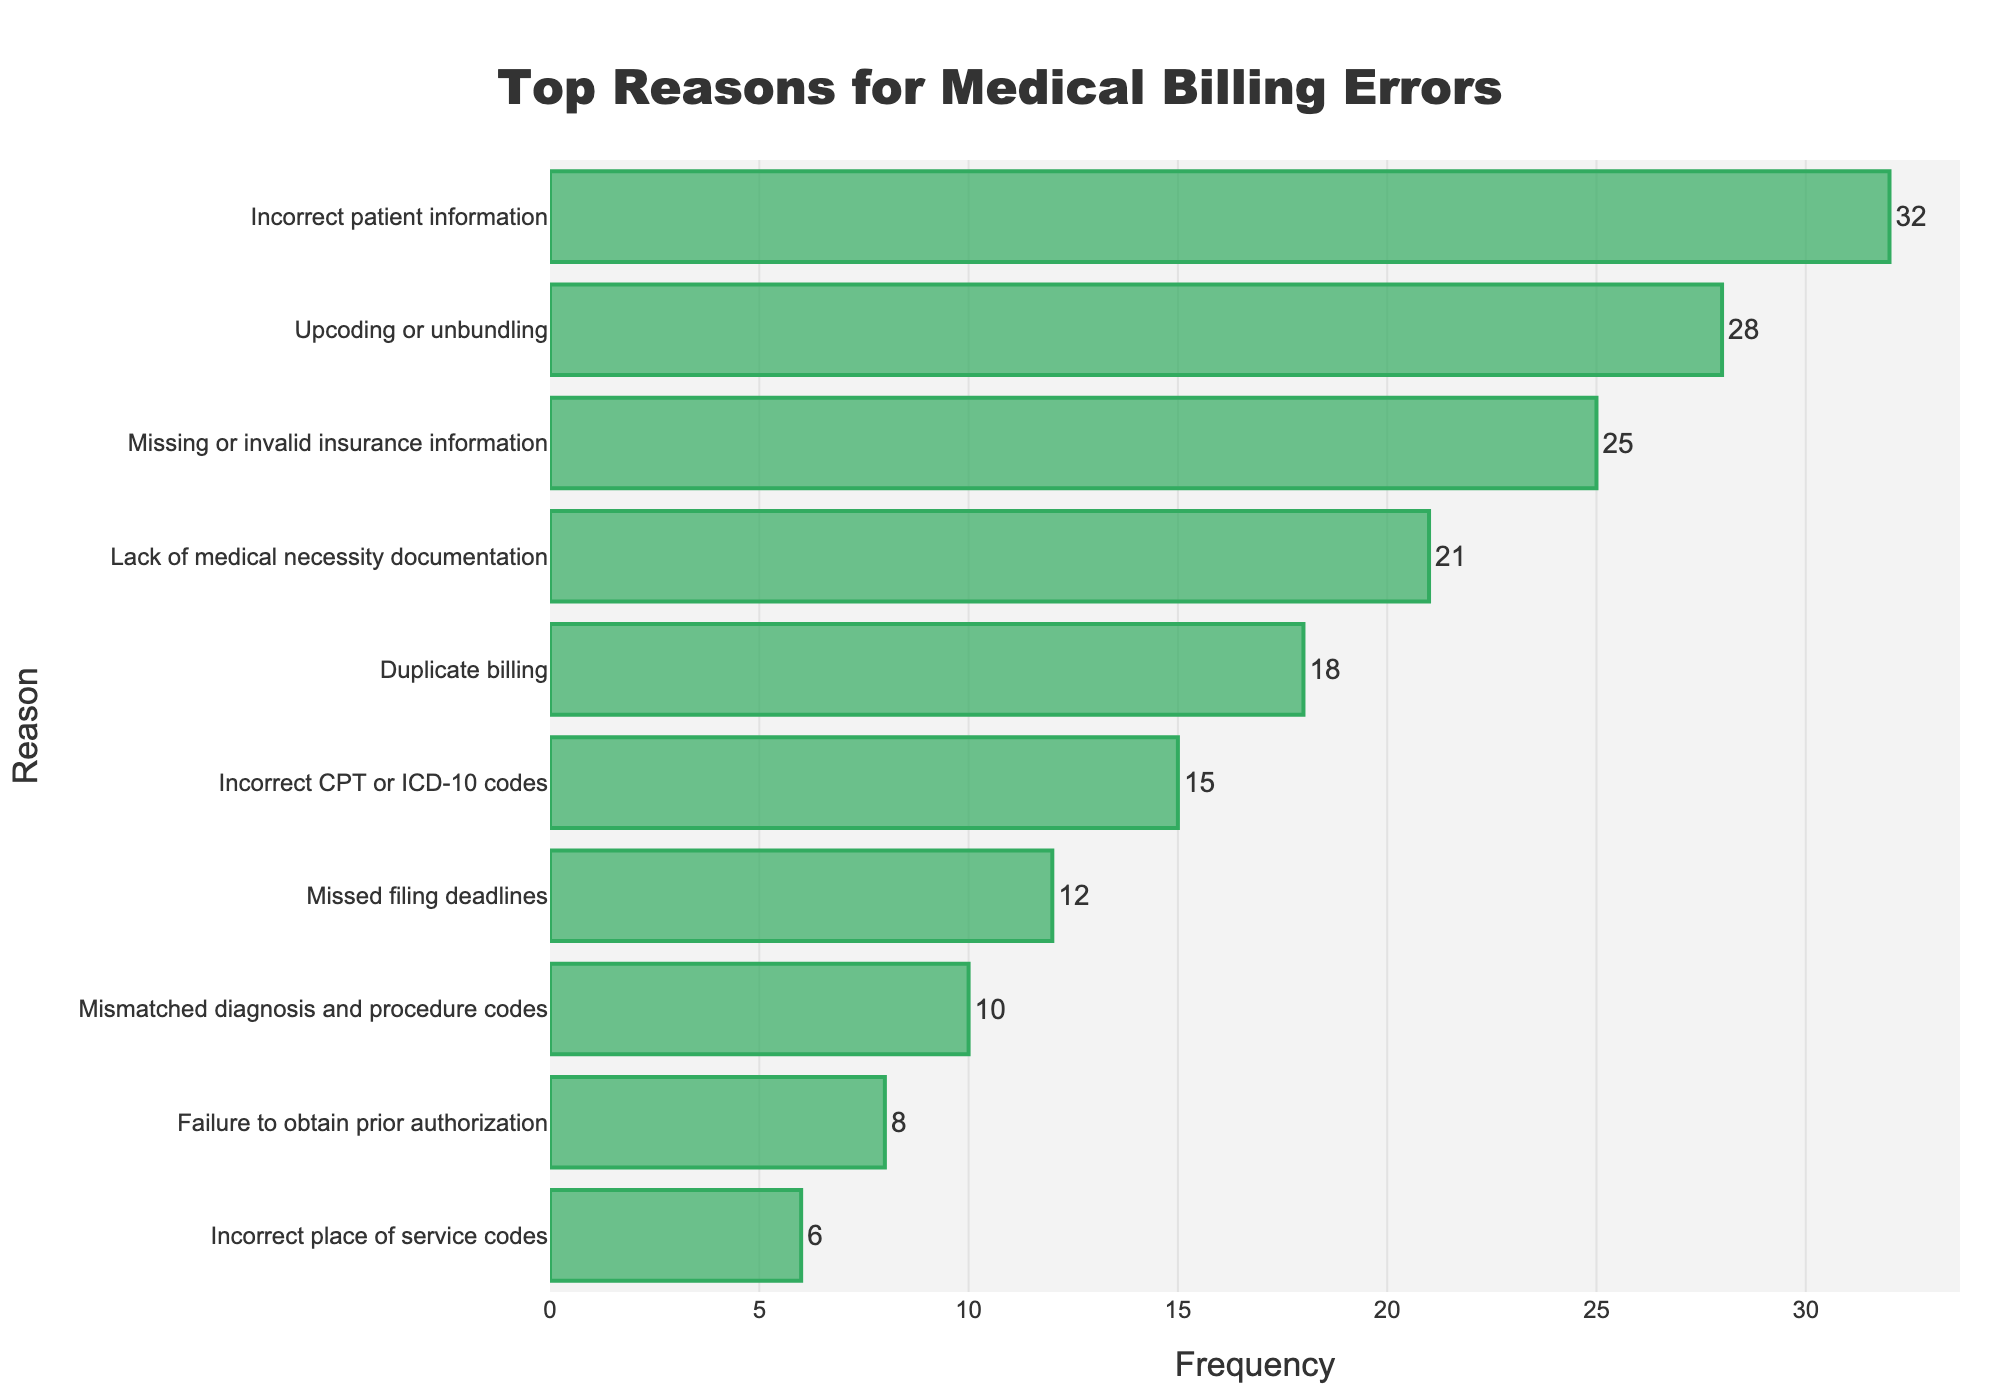What's the most common reason for medical billing errors? The most common reason for medical billing errors is the one with the highest frequency. From the figure, the longest bar corresponds to "Incorrect patient information" with a frequency of 32. Therefore, it's the most common reason.
Answer: Incorrect patient information Which reason has a higher frequency: "Upcoding or unbundling" or "Duplicate billing"? To compare, look at the bars for "Upcoding or unbundling" and "Duplicate billing." "Upcoding or unbundling" has a frequency of 28, while "Duplicate billing" has a frequency of 18. Therefore, "Upcoding or unbundling" has a higher frequency.
Answer: Upcoding or unbundling What's the combined frequency of the top three reasons for medical billing errors? The top three reasons by frequency are "Incorrect patient information" (32), "Upcoding or unbundling" (28), and "Missing or invalid insurance information" (25). Adding these frequencies gives 32 + 28 + 25 = 85.
Answer: 85 Are there any reasons for medical billing errors with a frequency less than 10? Identify the reasons with frequencies shown by shorter bars that are less than 10. The reasons "Failure to obtain prior authorization" (8) and "Incorrect place of service codes" (6) both have frequencies less than 10.
Answer: Yes What is the frequency difference between "Lack of medical necessity documentation" and "Incorrect CPT or ICD-10 codes"? Find the frequencies for "Lack of medical necessity documentation" (21) and "Incorrect CPT or ICD-10 codes" (15) and subtract the smaller from the larger: 21 - 15 = 6.
Answer: 6 How does the frequency of "Missed filing deadlines" compare to the median frequency of all reasons listed? List frequencies: 32, 28, 25, 21, 18, 15, 12, 10, 8, 6. To find the median, order them: 6, 8, 10, 12, 15, 18, 21, 25, 28, 32. The middle values are 15 and 18. Average these to get the median frequency: (15 + 18) / 2 = 16.5. "Missed filing deadlines" has a frequency of 12, which is less than the median of 16.5.
Answer: Less than What percentage of the total frequency is due to "Incorrect patient information"? Calculate the total frequency: 32 + 28 + 25 + 21 + 18 + 15 + 12 + 10 + 8 + 6 = 175. The percentage is (32 / 175) * 100 ≈ 18.29%.
Answer: 18.29% Which is the least common reason for medical billing errors? The least common reason for medical billing errors is the one with the smallest frequency. From the figure, the shortest bar corresponds to "Incorrect place of service codes" with a frequency of 6.
Answer: Incorrect place of service codes Of the reasons listed, which two have frequencies closest to each other? Look for the pairs with closely matching frequencies. "Mismatched diagnosis and procedure codes" (10) and "Failure to obtain prior authorization" (8) have the closest frequencies. The difference is only 2.
Answer: Mismatched diagnosis and procedure codes and Failure to obtain prior authorization What is the total frequency of errors relating to incorrect coding, including "Incorrect CPT or ICD-10 codes" and "Mismatched diagnosis and procedure codes"? Add the frequencies of "Incorrect CPT or ICD-10 codes" (15) and "Mismatched diagnosis and procedure codes" (10): 15 + 10 = 25.
Answer: 25 